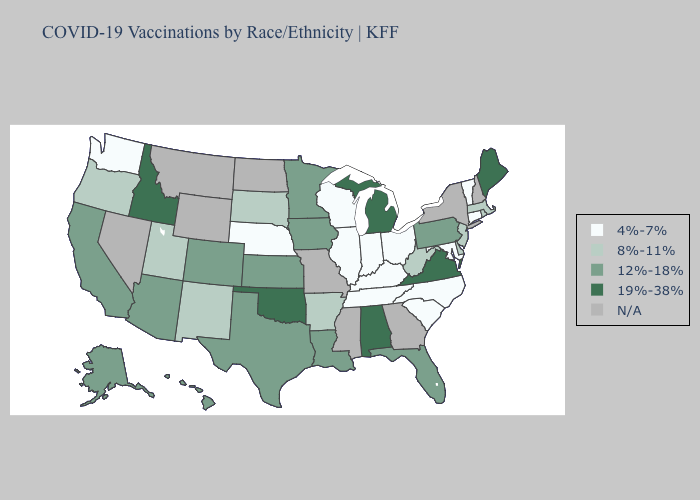Which states have the lowest value in the USA?
Write a very short answer. Connecticut, Illinois, Indiana, Kentucky, Maryland, Nebraska, North Carolina, Ohio, South Carolina, Tennessee, Vermont, Washington, Wisconsin. Name the states that have a value in the range 19%-38%?
Be succinct. Alabama, Idaho, Maine, Michigan, Oklahoma, Virginia. Among the states that border Alabama , does Florida have the lowest value?
Be succinct. No. What is the lowest value in the Northeast?
Answer briefly. 4%-7%. What is the value of Massachusetts?
Give a very brief answer. 8%-11%. Name the states that have a value in the range N/A?
Answer briefly. Georgia, Mississippi, Missouri, Montana, Nevada, New Hampshire, New York, North Dakota, Wyoming. Name the states that have a value in the range 12%-18%?
Concise answer only. Alaska, Arizona, California, Colorado, Florida, Hawaii, Iowa, Kansas, Louisiana, Minnesota, Pennsylvania, Texas. What is the value of South Carolina?
Write a very short answer. 4%-7%. Among the states that border North Dakota , which have the highest value?
Write a very short answer. Minnesota. What is the value of Texas?
Quick response, please. 12%-18%. Does Oregon have the highest value in the USA?
Concise answer only. No. Among the states that border Pennsylvania , does Ohio have the highest value?
Answer briefly. No. Does Arkansas have the highest value in the South?
Keep it brief. No. Does Washington have the lowest value in the West?
Short answer required. Yes. 